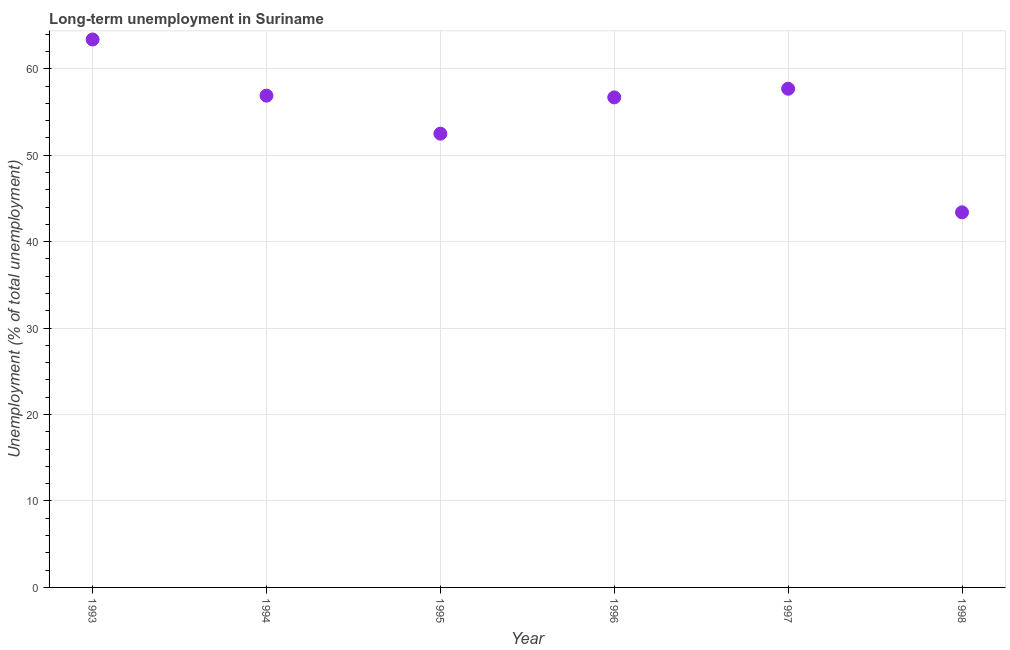What is the long-term unemployment in 1994?
Offer a terse response. 56.9. Across all years, what is the maximum long-term unemployment?
Your answer should be compact. 63.4. Across all years, what is the minimum long-term unemployment?
Provide a short and direct response. 43.4. What is the sum of the long-term unemployment?
Make the answer very short. 330.6. What is the difference between the long-term unemployment in 1994 and 1995?
Keep it short and to the point. 4.4. What is the average long-term unemployment per year?
Provide a succinct answer. 55.1. What is the median long-term unemployment?
Your response must be concise. 56.8. In how many years, is the long-term unemployment greater than 24 %?
Provide a short and direct response. 6. What is the ratio of the long-term unemployment in 1993 to that in 1996?
Ensure brevity in your answer.  1.12. Is the long-term unemployment in 1995 less than that in 1996?
Make the answer very short. Yes. Is the difference between the long-term unemployment in 1996 and 1998 greater than the difference between any two years?
Offer a terse response. No. What is the difference between the highest and the second highest long-term unemployment?
Provide a succinct answer. 5.7. Is the sum of the long-term unemployment in 1996 and 1997 greater than the maximum long-term unemployment across all years?
Ensure brevity in your answer.  Yes. In how many years, is the long-term unemployment greater than the average long-term unemployment taken over all years?
Ensure brevity in your answer.  4. Does the long-term unemployment monotonically increase over the years?
Your answer should be very brief. No. Does the graph contain any zero values?
Ensure brevity in your answer.  No. Does the graph contain grids?
Ensure brevity in your answer.  Yes. What is the title of the graph?
Offer a terse response. Long-term unemployment in Suriname. What is the label or title of the Y-axis?
Offer a very short reply. Unemployment (% of total unemployment). What is the Unemployment (% of total unemployment) in 1993?
Your answer should be compact. 63.4. What is the Unemployment (% of total unemployment) in 1994?
Make the answer very short. 56.9. What is the Unemployment (% of total unemployment) in 1995?
Provide a short and direct response. 52.5. What is the Unemployment (% of total unemployment) in 1996?
Provide a short and direct response. 56.7. What is the Unemployment (% of total unemployment) in 1997?
Keep it short and to the point. 57.7. What is the Unemployment (% of total unemployment) in 1998?
Ensure brevity in your answer.  43.4. What is the difference between the Unemployment (% of total unemployment) in 1993 and 1998?
Offer a terse response. 20. What is the difference between the Unemployment (% of total unemployment) in 1994 and 1996?
Give a very brief answer. 0.2. What is the difference between the Unemployment (% of total unemployment) in 1994 and 1997?
Your answer should be very brief. -0.8. What is the difference between the Unemployment (% of total unemployment) in 1995 and 1996?
Make the answer very short. -4.2. What is the difference between the Unemployment (% of total unemployment) in 1995 and 1997?
Offer a terse response. -5.2. What is the difference between the Unemployment (% of total unemployment) in 1996 and 1997?
Offer a terse response. -1. What is the ratio of the Unemployment (% of total unemployment) in 1993 to that in 1994?
Provide a short and direct response. 1.11. What is the ratio of the Unemployment (% of total unemployment) in 1993 to that in 1995?
Provide a succinct answer. 1.21. What is the ratio of the Unemployment (% of total unemployment) in 1993 to that in 1996?
Your answer should be compact. 1.12. What is the ratio of the Unemployment (% of total unemployment) in 1993 to that in 1997?
Provide a short and direct response. 1.1. What is the ratio of the Unemployment (% of total unemployment) in 1993 to that in 1998?
Offer a very short reply. 1.46. What is the ratio of the Unemployment (% of total unemployment) in 1994 to that in 1995?
Ensure brevity in your answer.  1.08. What is the ratio of the Unemployment (% of total unemployment) in 1994 to that in 1997?
Offer a terse response. 0.99. What is the ratio of the Unemployment (% of total unemployment) in 1994 to that in 1998?
Give a very brief answer. 1.31. What is the ratio of the Unemployment (% of total unemployment) in 1995 to that in 1996?
Make the answer very short. 0.93. What is the ratio of the Unemployment (% of total unemployment) in 1995 to that in 1997?
Provide a short and direct response. 0.91. What is the ratio of the Unemployment (% of total unemployment) in 1995 to that in 1998?
Offer a very short reply. 1.21. What is the ratio of the Unemployment (% of total unemployment) in 1996 to that in 1997?
Provide a succinct answer. 0.98. What is the ratio of the Unemployment (% of total unemployment) in 1996 to that in 1998?
Offer a very short reply. 1.31. What is the ratio of the Unemployment (% of total unemployment) in 1997 to that in 1998?
Offer a very short reply. 1.33. 